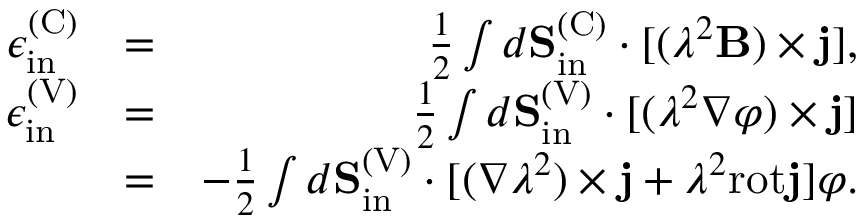Convert formula to latex. <formula><loc_0><loc_0><loc_500><loc_500>\begin{array} { r l r } { \epsilon _ { i n } ^ { ( C ) } } & { = } & { \frac { 1 } { 2 } \int d { S } _ { i n } ^ { ( C ) } \cdot [ ( \lambda ^ { 2 } { B } ) \times { j } ] , } \\ { \epsilon _ { i n } ^ { ( V ) } } & { = } & { \frac { 1 } { 2 } \int d { S } _ { i n } ^ { ( V ) } \cdot [ ( \lambda ^ { 2 } \nabla \varphi ) \times { j } ] } \\ & { = } & { - \frac { 1 } { 2 } \int d { S } _ { i n } ^ { ( V ) } \cdot [ ( \nabla \lambda ^ { 2 } ) \times { j } + \lambda ^ { 2 } r o t { j } ] \varphi . } \end{array}</formula> 